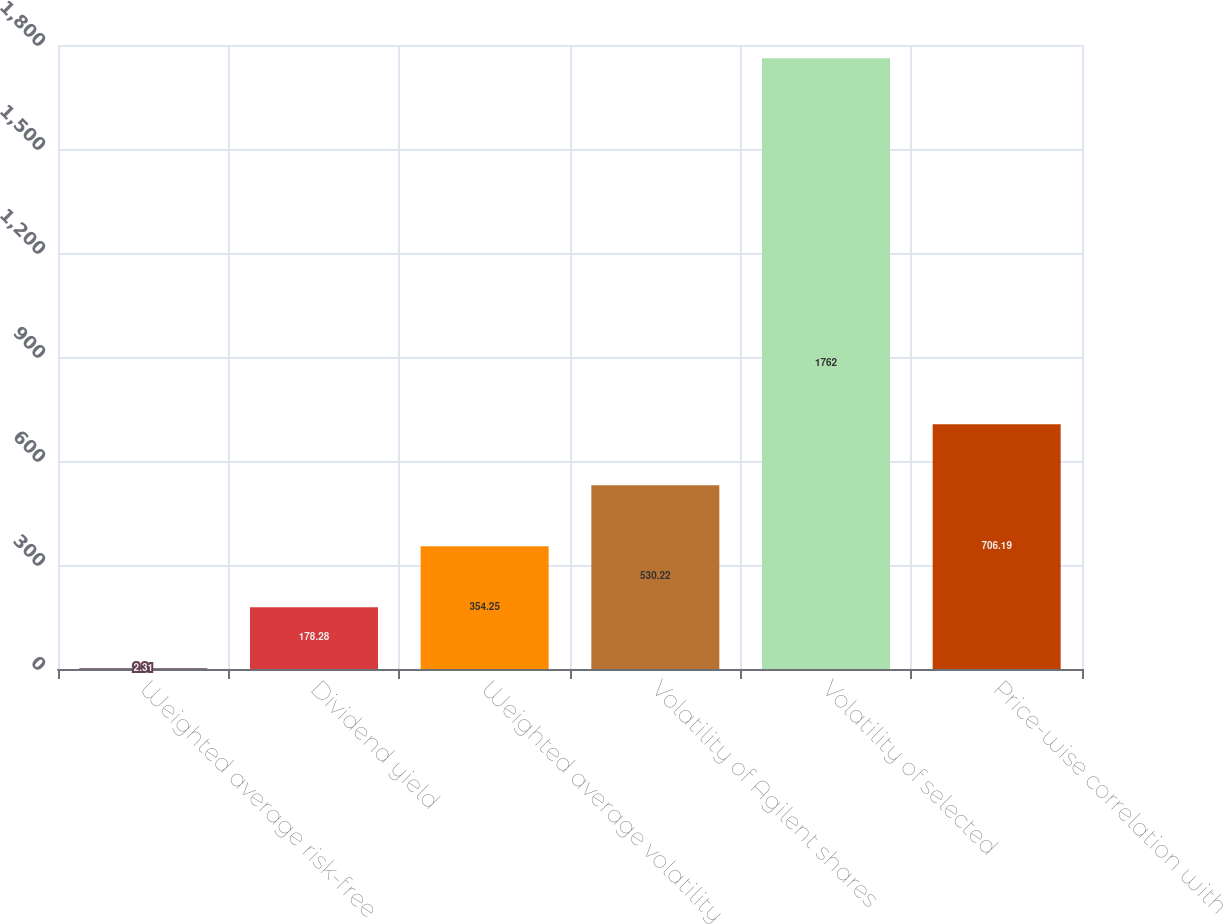Convert chart to OTSL. <chart><loc_0><loc_0><loc_500><loc_500><bar_chart><fcel>Weighted average risk-free<fcel>Dividend yield<fcel>Weighted average volatility<fcel>Volatility of Agilent shares<fcel>Volatility of selected<fcel>Price-wise correlation with<nl><fcel>2.31<fcel>178.28<fcel>354.25<fcel>530.22<fcel>1762<fcel>706.19<nl></chart> 